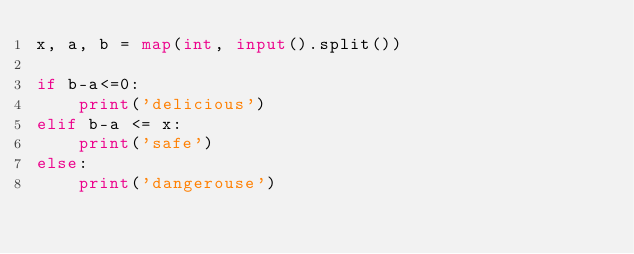Convert code to text. <code><loc_0><loc_0><loc_500><loc_500><_Python_>x, a, b = map(int, input().split())

if b-a<=0:
    print('delicious')
elif b-a <= x:
    print('safe')
else:
    print('dangerouse')
</code> 